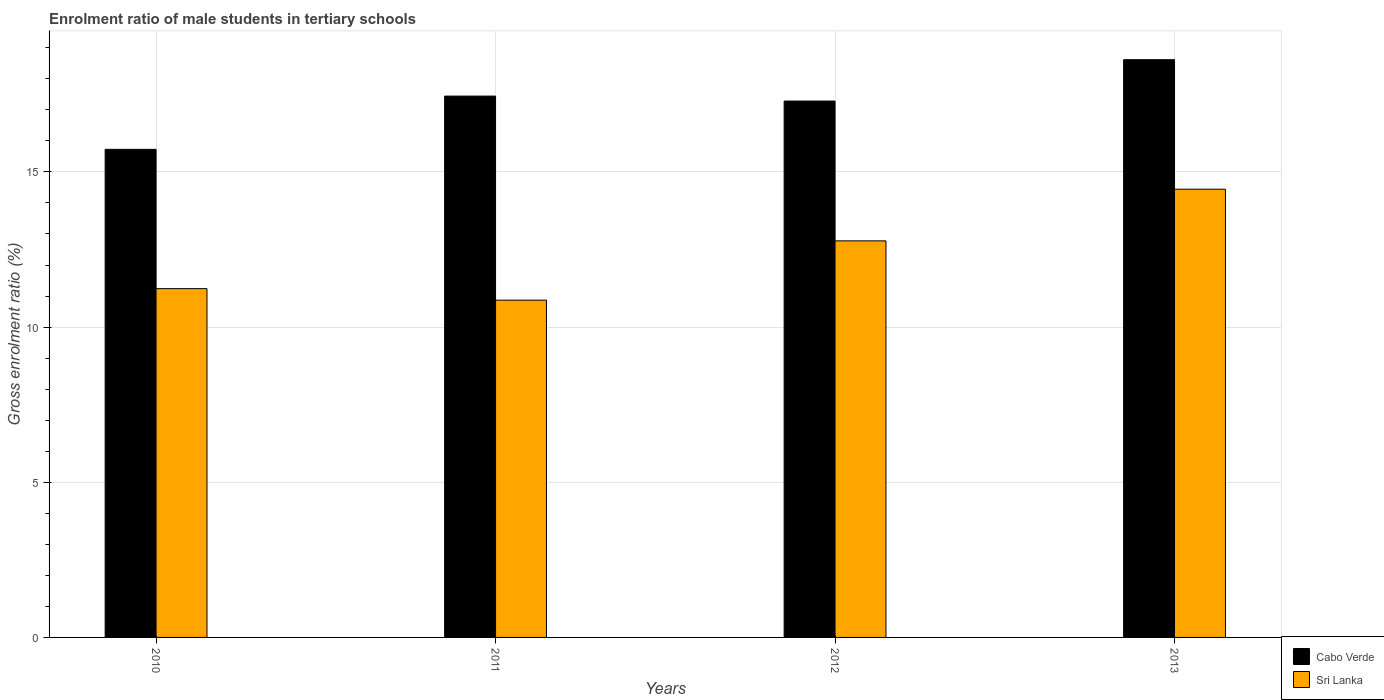How many different coloured bars are there?
Offer a very short reply. 2. Are the number of bars per tick equal to the number of legend labels?
Your answer should be compact. Yes. Are the number of bars on each tick of the X-axis equal?
Offer a terse response. Yes. What is the label of the 4th group of bars from the left?
Your answer should be very brief. 2013. In how many cases, is the number of bars for a given year not equal to the number of legend labels?
Your response must be concise. 0. What is the enrolment ratio of male students in tertiary schools in Sri Lanka in 2013?
Ensure brevity in your answer.  14.44. Across all years, what is the maximum enrolment ratio of male students in tertiary schools in Cabo Verde?
Give a very brief answer. 18.62. Across all years, what is the minimum enrolment ratio of male students in tertiary schools in Sri Lanka?
Keep it short and to the point. 10.87. In which year was the enrolment ratio of male students in tertiary schools in Sri Lanka maximum?
Your answer should be very brief. 2013. What is the total enrolment ratio of male students in tertiary schools in Cabo Verde in the graph?
Your answer should be very brief. 69.07. What is the difference between the enrolment ratio of male students in tertiary schools in Cabo Verde in 2010 and that in 2013?
Your answer should be very brief. -2.89. What is the difference between the enrolment ratio of male students in tertiary schools in Cabo Verde in 2010 and the enrolment ratio of male students in tertiary schools in Sri Lanka in 2012?
Provide a short and direct response. 2.95. What is the average enrolment ratio of male students in tertiary schools in Sri Lanka per year?
Ensure brevity in your answer.  12.33. In the year 2013, what is the difference between the enrolment ratio of male students in tertiary schools in Sri Lanka and enrolment ratio of male students in tertiary schools in Cabo Verde?
Your answer should be very brief. -4.17. In how many years, is the enrolment ratio of male students in tertiary schools in Cabo Verde greater than 9 %?
Your response must be concise. 4. What is the ratio of the enrolment ratio of male students in tertiary schools in Sri Lanka in 2010 to that in 2013?
Your response must be concise. 0.78. Is the difference between the enrolment ratio of male students in tertiary schools in Sri Lanka in 2011 and 2013 greater than the difference between the enrolment ratio of male students in tertiary schools in Cabo Verde in 2011 and 2013?
Provide a succinct answer. No. What is the difference between the highest and the second highest enrolment ratio of male students in tertiary schools in Sri Lanka?
Keep it short and to the point. 1.67. What is the difference between the highest and the lowest enrolment ratio of male students in tertiary schools in Cabo Verde?
Your response must be concise. 2.89. What does the 2nd bar from the left in 2011 represents?
Offer a very short reply. Sri Lanka. What does the 1st bar from the right in 2012 represents?
Your answer should be compact. Sri Lanka. How many bars are there?
Your response must be concise. 8. Are all the bars in the graph horizontal?
Offer a terse response. No. What is the title of the graph?
Offer a terse response. Enrolment ratio of male students in tertiary schools. What is the label or title of the Y-axis?
Your answer should be compact. Gross enrolment ratio (%). What is the Gross enrolment ratio (%) in Cabo Verde in 2010?
Keep it short and to the point. 15.73. What is the Gross enrolment ratio (%) in Sri Lanka in 2010?
Your answer should be compact. 11.24. What is the Gross enrolment ratio (%) in Cabo Verde in 2011?
Give a very brief answer. 17.44. What is the Gross enrolment ratio (%) in Sri Lanka in 2011?
Your answer should be compact. 10.87. What is the Gross enrolment ratio (%) in Cabo Verde in 2012?
Provide a succinct answer. 17.28. What is the Gross enrolment ratio (%) of Sri Lanka in 2012?
Your answer should be very brief. 12.78. What is the Gross enrolment ratio (%) in Cabo Verde in 2013?
Give a very brief answer. 18.62. What is the Gross enrolment ratio (%) of Sri Lanka in 2013?
Your response must be concise. 14.44. Across all years, what is the maximum Gross enrolment ratio (%) of Cabo Verde?
Your answer should be very brief. 18.62. Across all years, what is the maximum Gross enrolment ratio (%) of Sri Lanka?
Your answer should be compact. 14.44. Across all years, what is the minimum Gross enrolment ratio (%) of Cabo Verde?
Ensure brevity in your answer.  15.73. Across all years, what is the minimum Gross enrolment ratio (%) of Sri Lanka?
Offer a terse response. 10.87. What is the total Gross enrolment ratio (%) of Cabo Verde in the graph?
Offer a very short reply. 69.07. What is the total Gross enrolment ratio (%) in Sri Lanka in the graph?
Make the answer very short. 49.33. What is the difference between the Gross enrolment ratio (%) of Cabo Verde in 2010 and that in 2011?
Provide a short and direct response. -1.72. What is the difference between the Gross enrolment ratio (%) of Sri Lanka in 2010 and that in 2011?
Keep it short and to the point. 0.37. What is the difference between the Gross enrolment ratio (%) in Cabo Verde in 2010 and that in 2012?
Your answer should be compact. -1.56. What is the difference between the Gross enrolment ratio (%) in Sri Lanka in 2010 and that in 2012?
Provide a succinct answer. -1.54. What is the difference between the Gross enrolment ratio (%) of Cabo Verde in 2010 and that in 2013?
Give a very brief answer. -2.89. What is the difference between the Gross enrolment ratio (%) in Sri Lanka in 2010 and that in 2013?
Offer a terse response. -3.2. What is the difference between the Gross enrolment ratio (%) in Cabo Verde in 2011 and that in 2012?
Offer a very short reply. 0.16. What is the difference between the Gross enrolment ratio (%) of Sri Lanka in 2011 and that in 2012?
Make the answer very short. -1.91. What is the difference between the Gross enrolment ratio (%) in Cabo Verde in 2011 and that in 2013?
Provide a succinct answer. -1.17. What is the difference between the Gross enrolment ratio (%) in Sri Lanka in 2011 and that in 2013?
Keep it short and to the point. -3.58. What is the difference between the Gross enrolment ratio (%) of Cabo Verde in 2012 and that in 2013?
Offer a very short reply. -1.33. What is the difference between the Gross enrolment ratio (%) of Sri Lanka in 2012 and that in 2013?
Provide a short and direct response. -1.67. What is the difference between the Gross enrolment ratio (%) in Cabo Verde in 2010 and the Gross enrolment ratio (%) in Sri Lanka in 2011?
Your answer should be compact. 4.86. What is the difference between the Gross enrolment ratio (%) in Cabo Verde in 2010 and the Gross enrolment ratio (%) in Sri Lanka in 2012?
Provide a short and direct response. 2.95. What is the difference between the Gross enrolment ratio (%) of Cabo Verde in 2010 and the Gross enrolment ratio (%) of Sri Lanka in 2013?
Give a very brief answer. 1.28. What is the difference between the Gross enrolment ratio (%) of Cabo Verde in 2011 and the Gross enrolment ratio (%) of Sri Lanka in 2012?
Your response must be concise. 4.67. What is the difference between the Gross enrolment ratio (%) of Cabo Verde in 2011 and the Gross enrolment ratio (%) of Sri Lanka in 2013?
Your answer should be very brief. 3. What is the difference between the Gross enrolment ratio (%) of Cabo Verde in 2012 and the Gross enrolment ratio (%) of Sri Lanka in 2013?
Ensure brevity in your answer.  2.84. What is the average Gross enrolment ratio (%) in Cabo Verde per year?
Your response must be concise. 17.27. What is the average Gross enrolment ratio (%) in Sri Lanka per year?
Your response must be concise. 12.33. In the year 2010, what is the difference between the Gross enrolment ratio (%) in Cabo Verde and Gross enrolment ratio (%) in Sri Lanka?
Offer a terse response. 4.49. In the year 2011, what is the difference between the Gross enrolment ratio (%) of Cabo Verde and Gross enrolment ratio (%) of Sri Lanka?
Your answer should be very brief. 6.58. In the year 2012, what is the difference between the Gross enrolment ratio (%) in Cabo Verde and Gross enrolment ratio (%) in Sri Lanka?
Make the answer very short. 4.51. In the year 2013, what is the difference between the Gross enrolment ratio (%) in Cabo Verde and Gross enrolment ratio (%) in Sri Lanka?
Ensure brevity in your answer.  4.17. What is the ratio of the Gross enrolment ratio (%) in Cabo Verde in 2010 to that in 2011?
Your answer should be compact. 0.9. What is the ratio of the Gross enrolment ratio (%) of Sri Lanka in 2010 to that in 2011?
Offer a very short reply. 1.03. What is the ratio of the Gross enrolment ratio (%) in Cabo Verde in 2010 to that in 2012?
Keep it short and to the point. 0.91. What is the ratio of the Gross enrolment ratio (%) in Sri Lanka in 2010 to that in 2012?
Your answer should be compact. 0.88. What is the ratio of the Gross enrolment ratio (%) of Cabo Verde in 2010 to that in 2013?
Give a very brief answer. 0.84. What is the ratio of the Gross enrolment ratio (%) in Sri Lanka in 2010 to that in 2013?
Offer a very short reply. 0.78. What is the ratio of the Gross enrolment ratio (%) of Cabo Verde in 2011 to that in 2012?
Offer a terse response. 1.01. What is the ratio of the Gross enrolment ratio (%) of Sri Lanka in 2011 to that in 2012?
Your answer should be compact. 0.85. What is the ratio of the Gross enrolment ratio (%) of Cabo Verde in 2011 to that in 2013?
Keep it short and to the point. 0.94. What is the ratio of the Gross enrolment ratio (%) of Sri Lanka in 2011 to that in 2013?
Offer a very short reply. 0.75. What is the ratio of the Gross enrolment ratio (%) in Cabo Verde in 2012 to that in 2013?
Your answer should be compact. 0.93. What is the ratio of the Gross enrolment ratio (%) of Sri Lanka in 2012 to that in 2013?
Your answer should be very brief. 0.88. What is the difference between the highest and the second highest Gross enrolment ratio (%) of Cabo Verde?
Give a very brief answer. 1.17. What is the difference between the highest and the second highest Gross enrolment ratio (%) in Sri Lanka?
Ensure brevity in your answer.  1.67. What is the difference between the highest and the lowest Gross enrolment ratio (%) of Cabo Verde?
Provide a succinct answer. 2.89. What is the difference between the highest and the lowest Gross enrolment ratio (%) of Sri Lanka?
Keep it short and to the point. 3.58. 